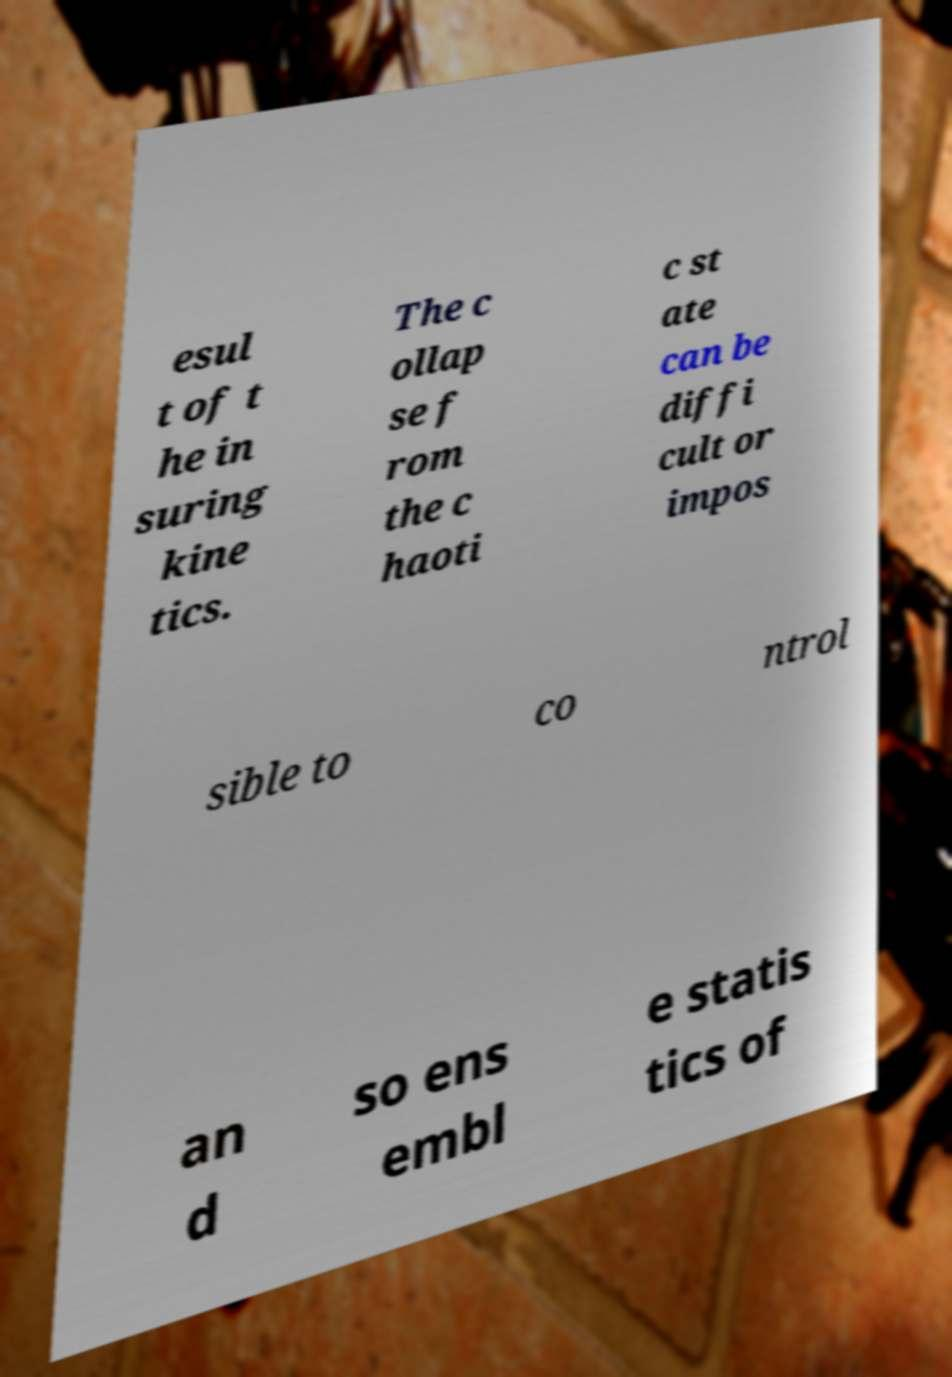Can you accurately transcribe the text from the provided image for me? esul t of t he in suring kine tics. The c ollap se f rom the c haoti c st ate can be diffi cult or impos sible to co ntrol an d so ens embl e statis tics of 